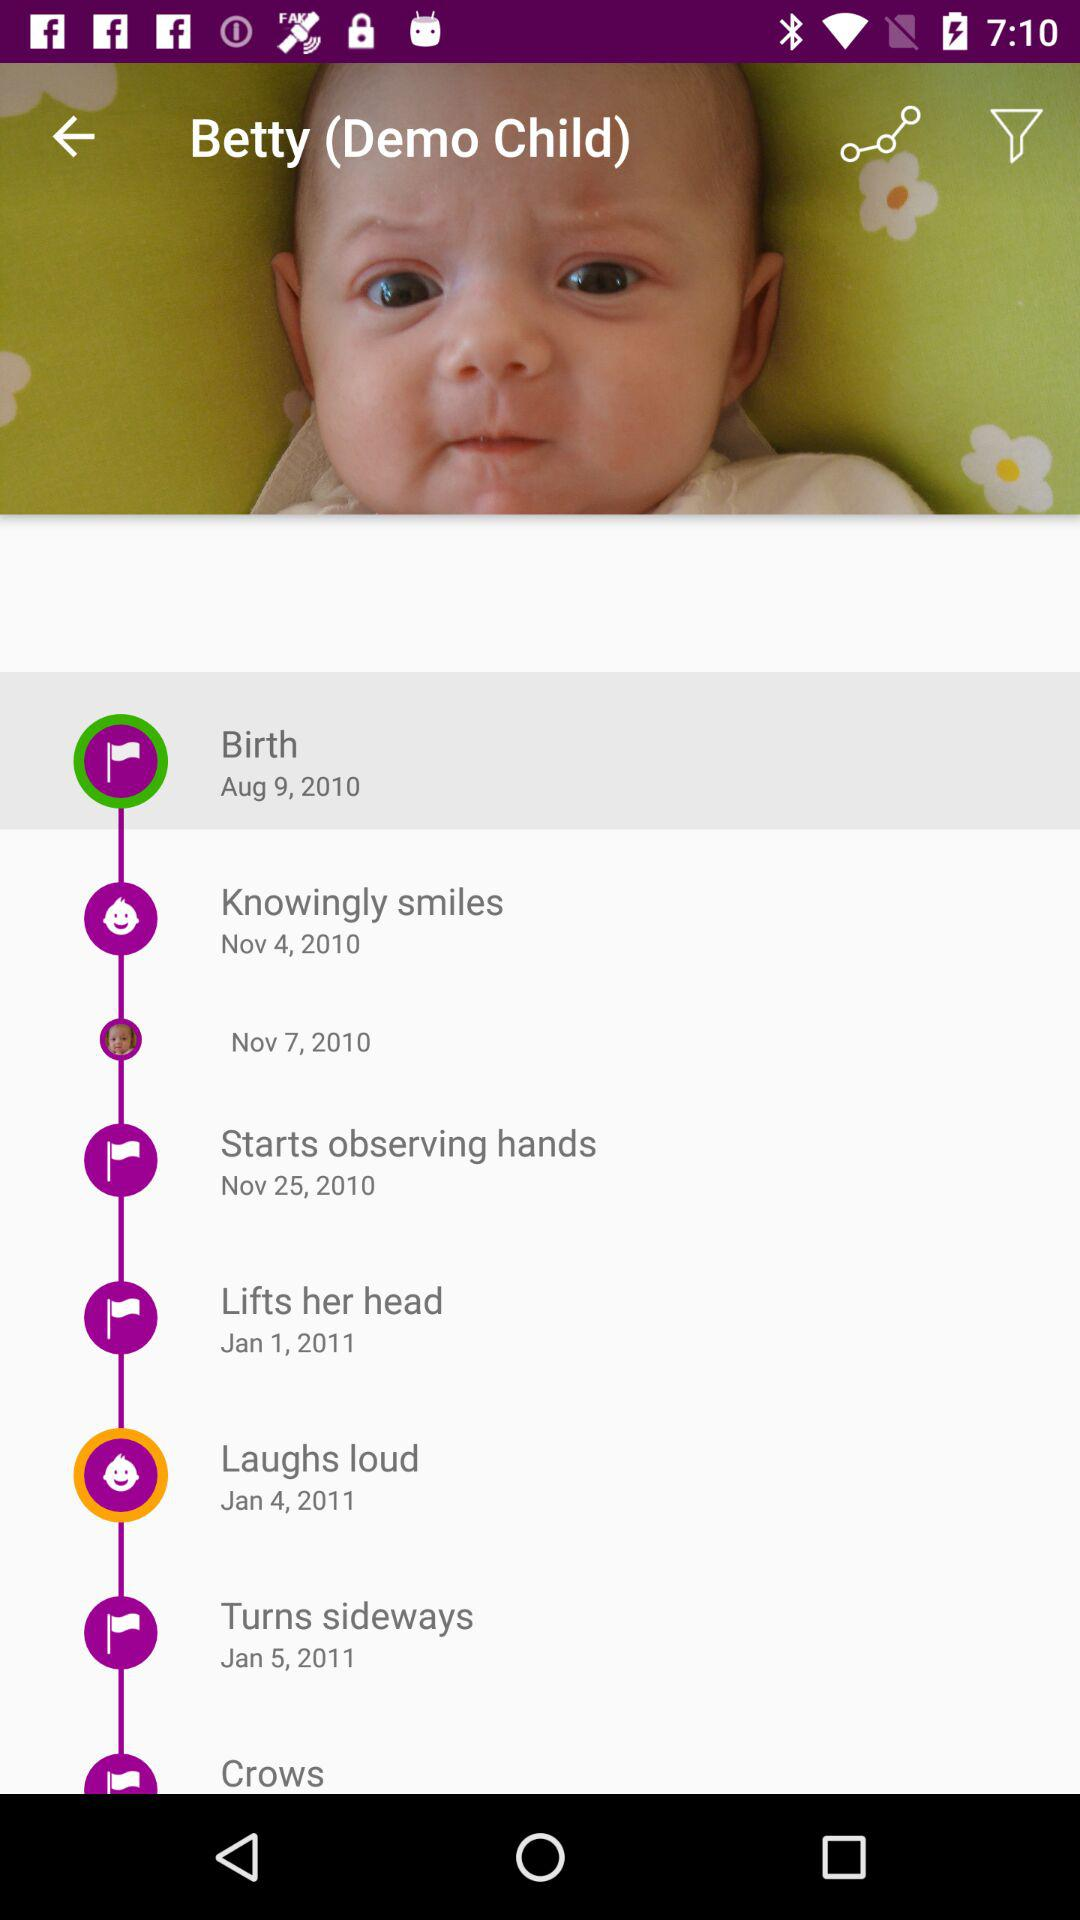How many of Betty's milestones are in the month of November?
Answer the question using a single word or phrase. 3 